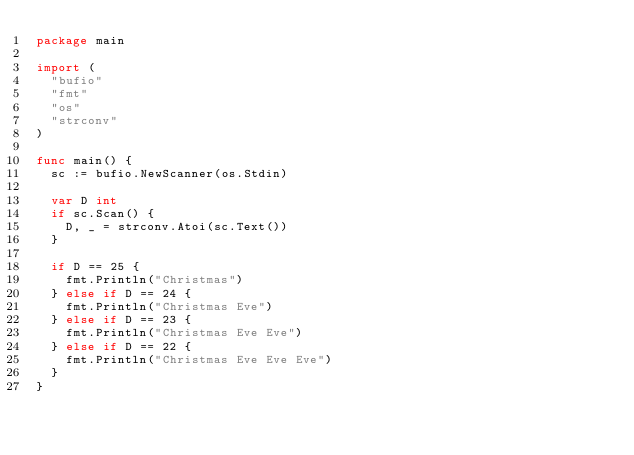<code> <loc_0><loc_0><loc_500><loc_500><_Go_>package main

import (
	"bufio"
	"fmt"
	"os"
	"strconv"
)

func main() {
	sc := bufio.NewScanner(os.Stdin)

	var D int
	if sc.Scan() {
		D, _ = strconv.Atoi(sc.Text())
	}

	if D == 25 {
		fmt.Println("Christmas")
	} else if D == 24 {
		fmt.Println("Christmas Eve")
	} else if D == 23 {
		fmt.Println("Christmas Eve Eve")
	} else if D == 22 {
		fmt.Println("Christmas Eve Eve Eve")
	}
}
</code> 